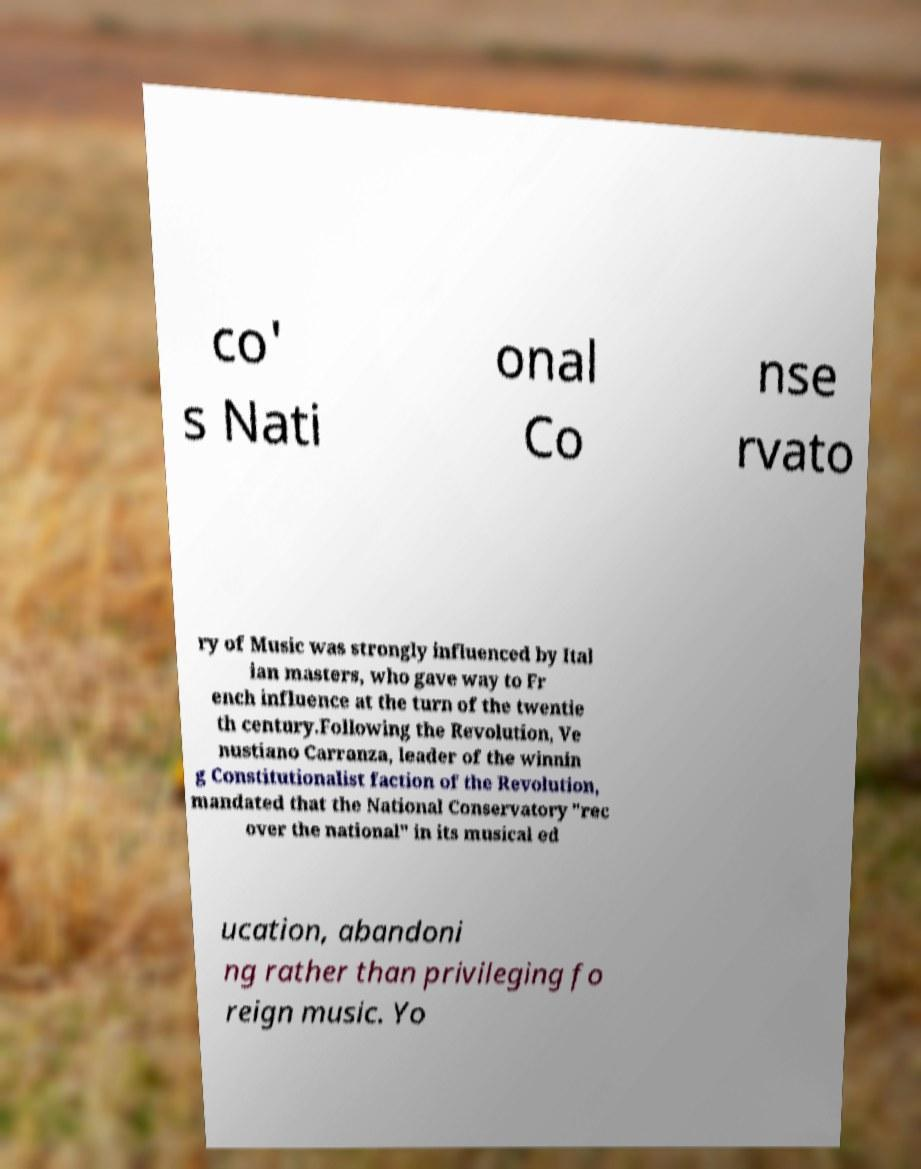Please identify and transcribe the text found in this image. co' s Nati onal Co nse rvato ry of Music was strongly influenced by Ital ian masters, who gave way to Fr ench influence at the turn of the twentie th century.Following the Revolution, Ve nustiano Carranza, leader of the winnin g Constitutionalist faction of the Revolution, mandated that the National Conservatory "rec over the national" in its musical ed ucation, abandoni ng rather than privileging fo reign music. Yo 